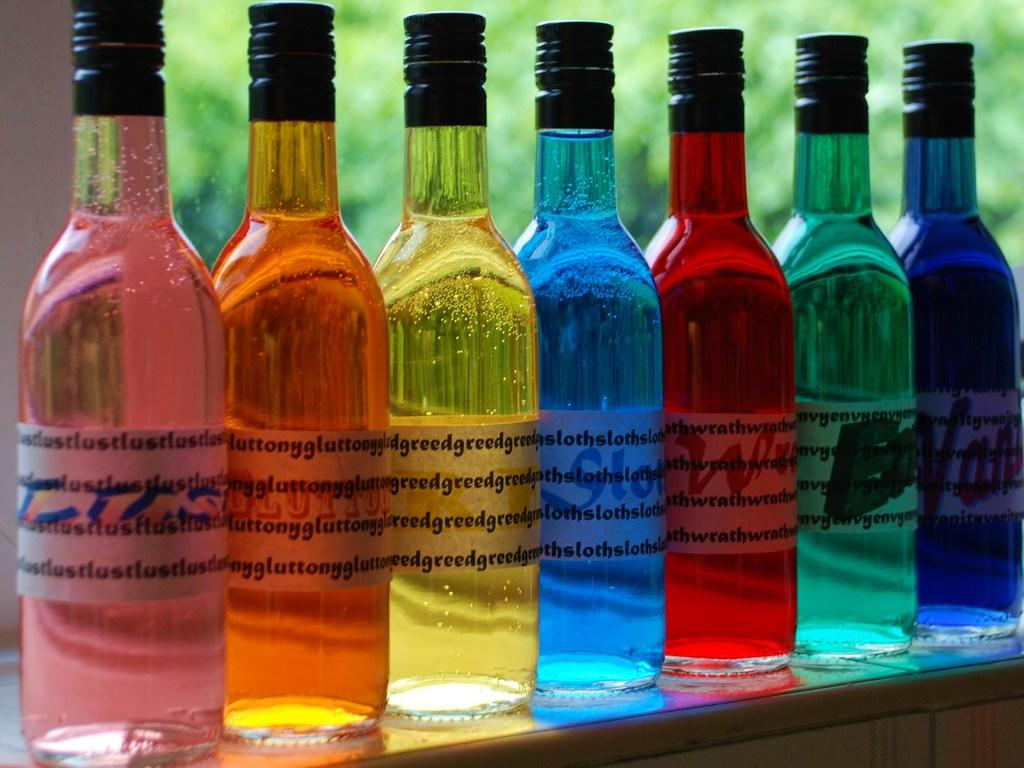<image>
Summarize the visual content of the image. A spectrum of brightly colored wine bottles, labels referring to the seven deadly sins, sit against a windowsill. 